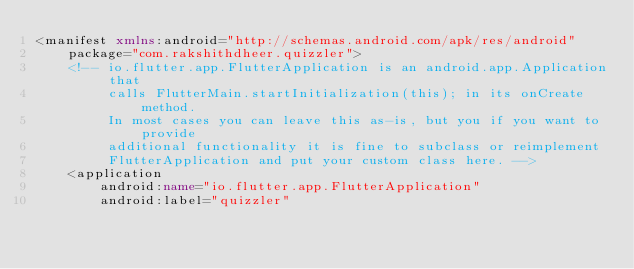<code> <loc_0><loc_0><loc_500><loc_500><_XML_><manifest xmlns:android="http://schemas.android.com/apk/res/android"
    package="com.rakshithdheer.quizzler">
    <!-- io.flutter.app.FlutterApplication is an android.app.Application that
         calls FlutterMain.startInitialization(this); in its onCreate method.
         In most cases you can leave this as-is, but you if you want to provide
         additional functionality it is fine to subclass or reimplement
         FlutterApplication and put your custom class here. -->
    <application
        android:name="io.flutter.app.FlutterApplication"
        android:label="quizzler"</code> 